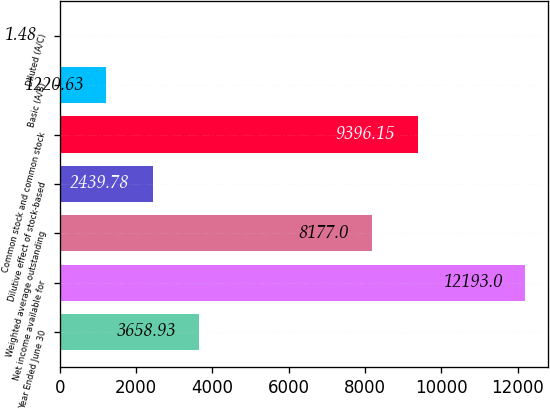Convert chart. <chart><loc_0><loc_0><loc_500><loc_500><bar_chart><fcel>Year Ended June 30<fcel>Net income available for<fcel>Weighted average outstanding<fcel>Dilutive effect of stock-based<fcel>Common stock and common stock<fcel>Basic (A/B)<fcel>Diluted (A/C)<nl><fcel>3658.93<fcel>12193<fcel>8177<fcel>2439.78<fcel>9396.15<fcel>1220.63<fcel>1.48<nl></chart> 